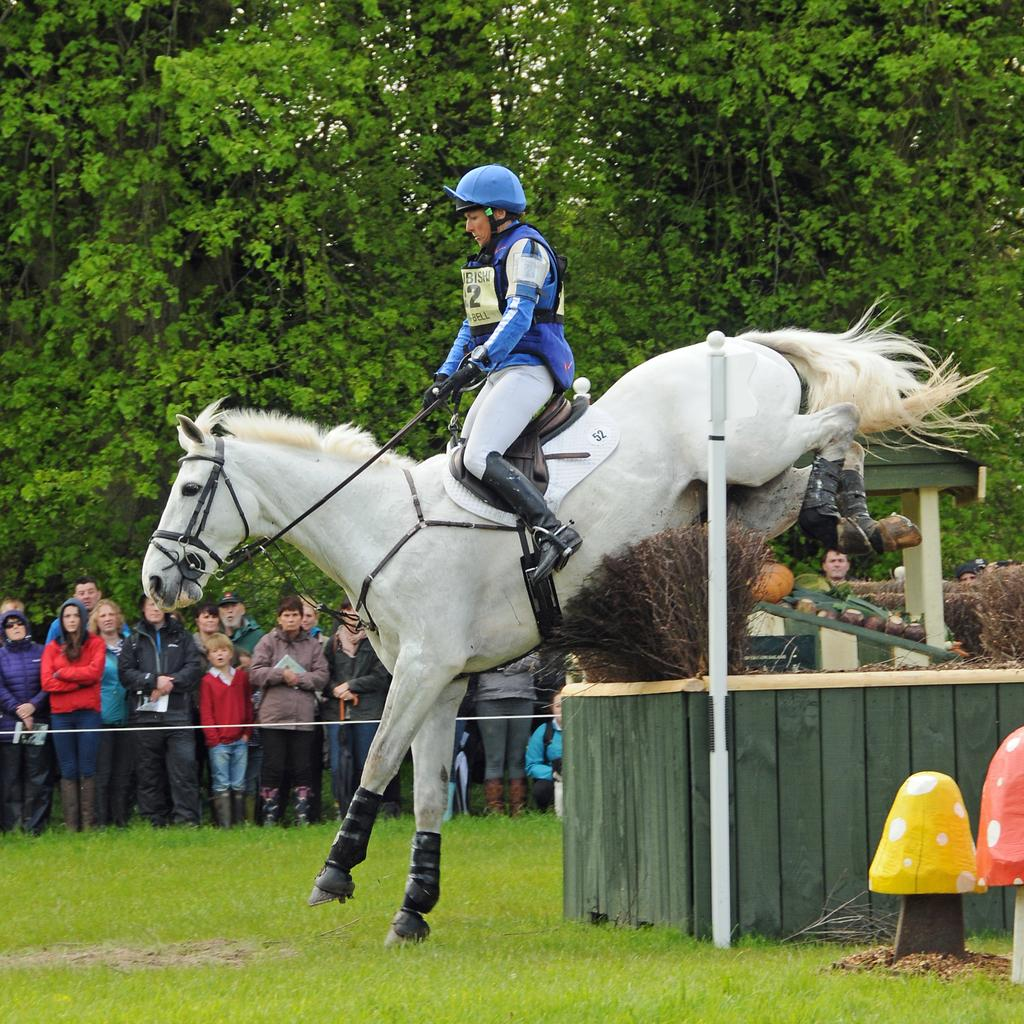What is the main subject of the image? There is a person riding a horse in the image. What type of terrain can be seen in the image? There is green grass visible in the image. Are there any other people present in the image? Yes, there are spectators in the image. What can be seen in the background of the image? Trees are present in the background of the image. What type of pear is being used for writing in the image? There is no pear or writing present in the image. 